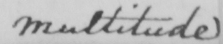Can you tell me what this handwritten text says? Multitude 